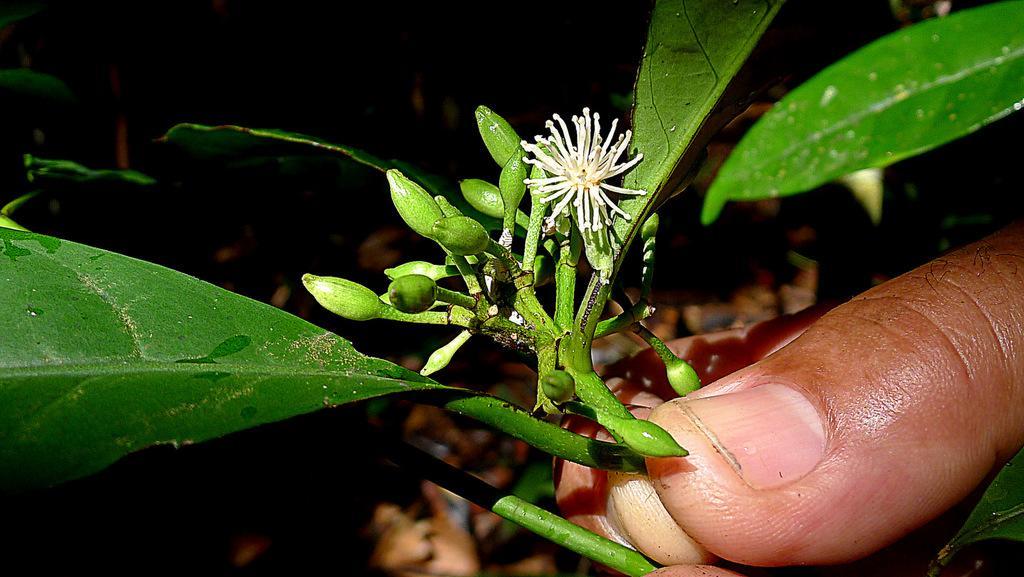How would you summarize this image in a sentence or two? At the bottom of the image we can see some fingers. In the fingers we can see some plants and flowers. 